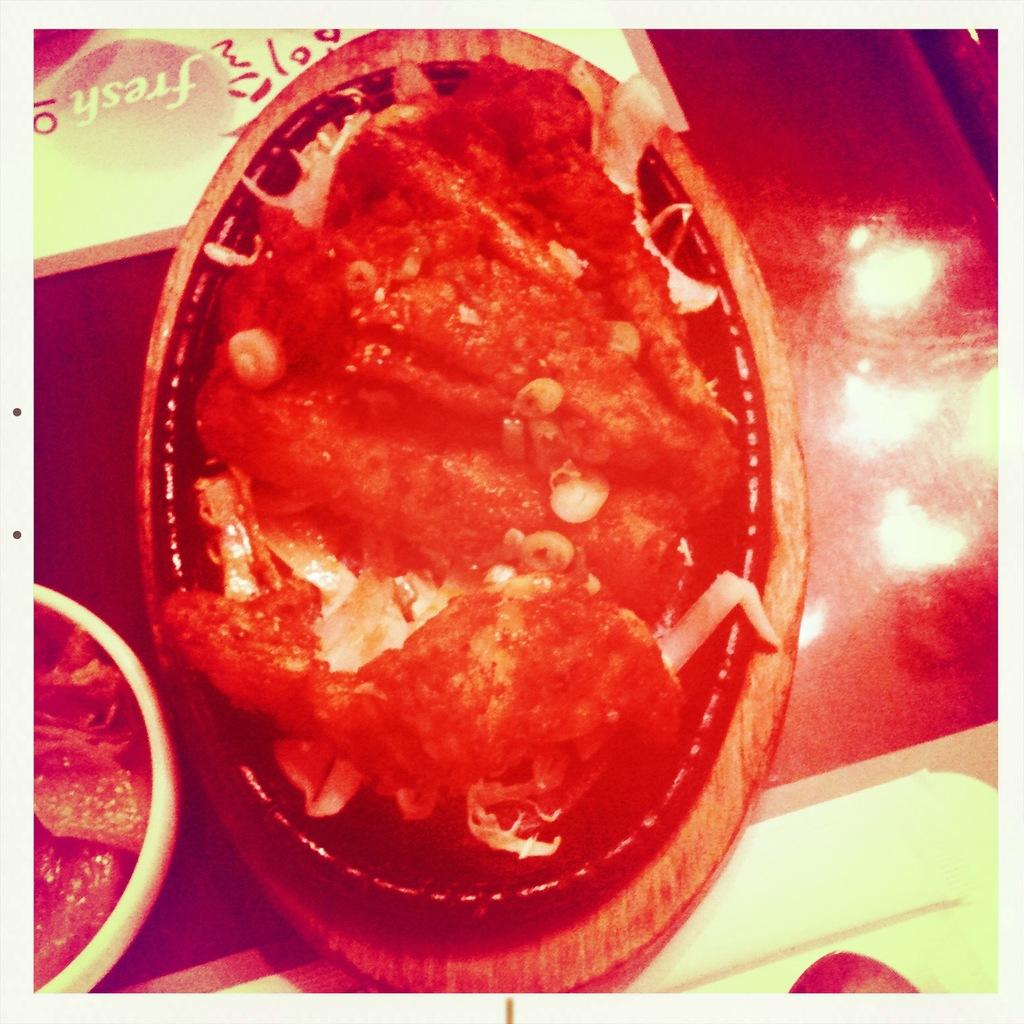What is on the plate that is visible in the image? There is food in a plate in the image. Where is the plate located in the image? The plate is placed on a table. Can you see a kite flying in the image? There is no kite visible in the image. Is there any money on the table in the image? The provided facts do not mention money being present in the image. 